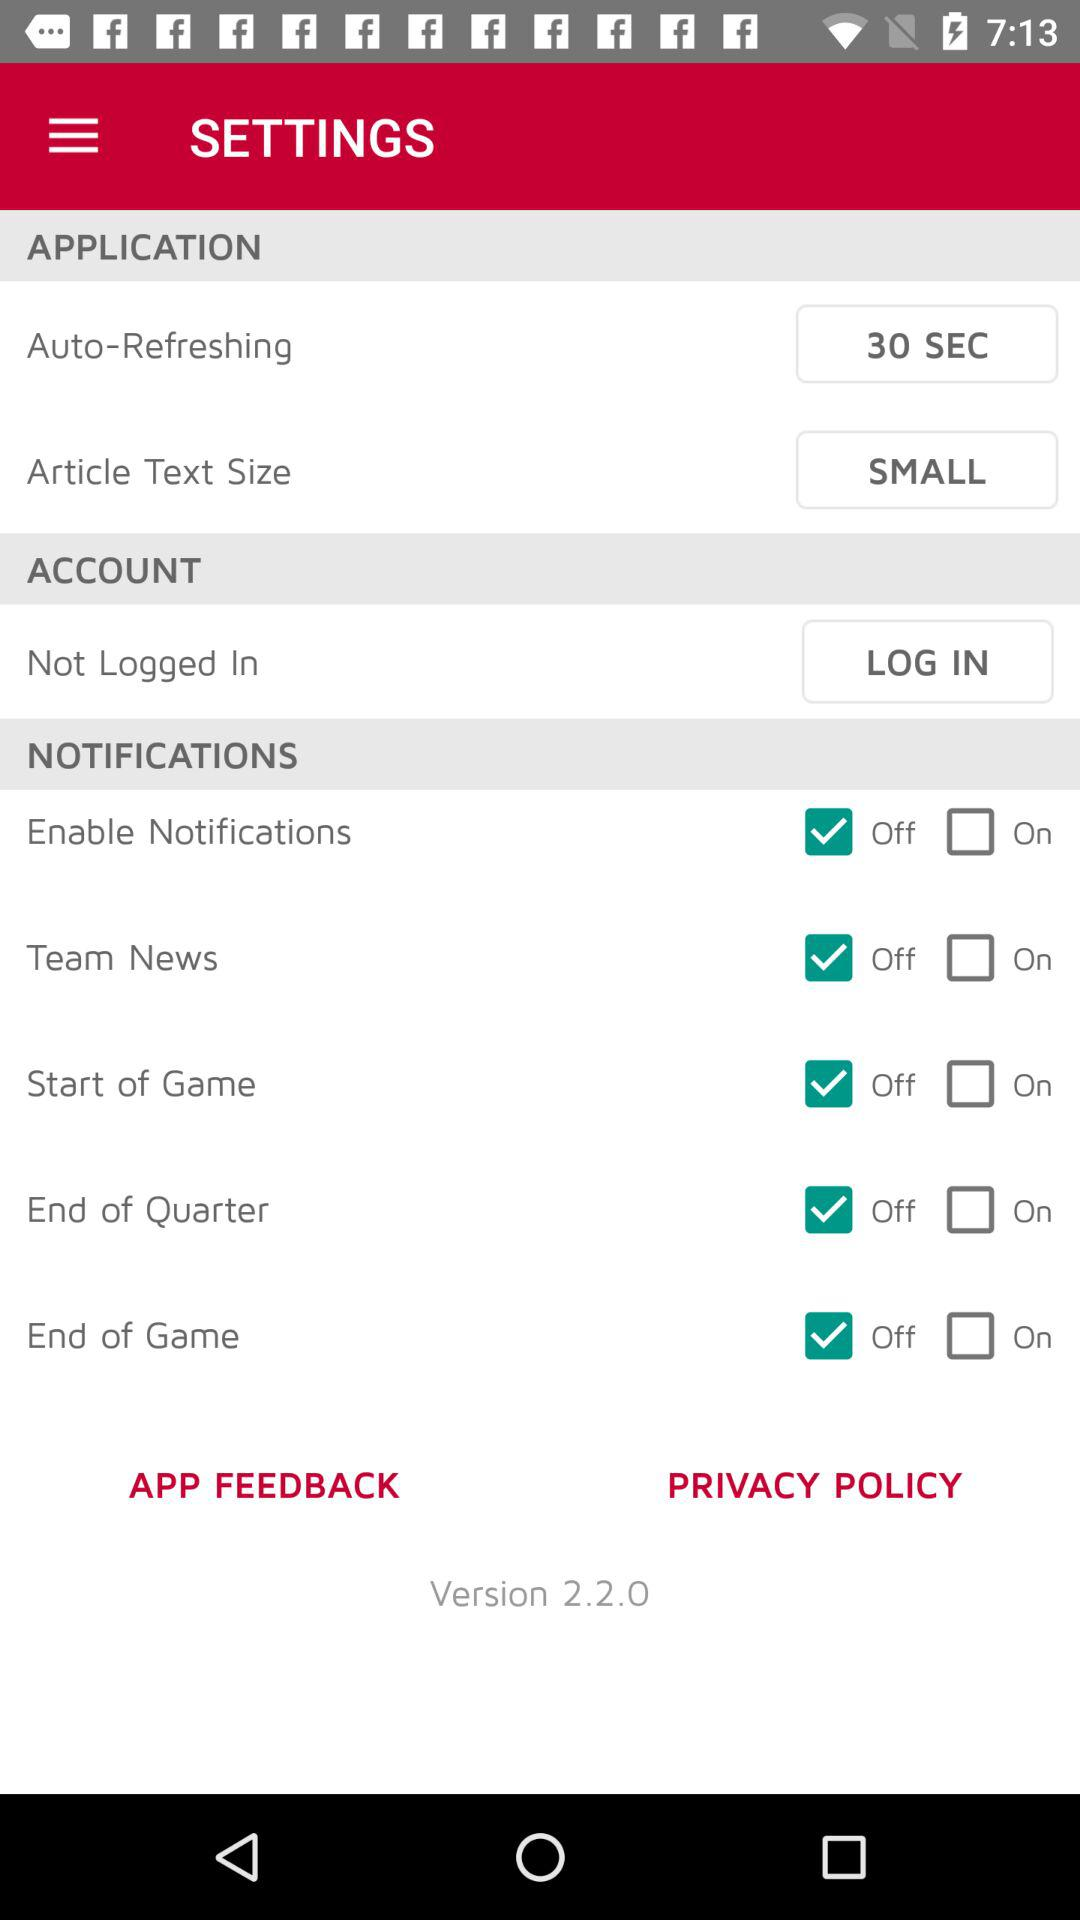What is the status of "Team News"? The status is "off". 